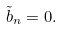Convert formula to latex. <formula><loc_0><loc_0><loc_500><loc_500>\tilde { b } _ { n } = 0 .</formula> 